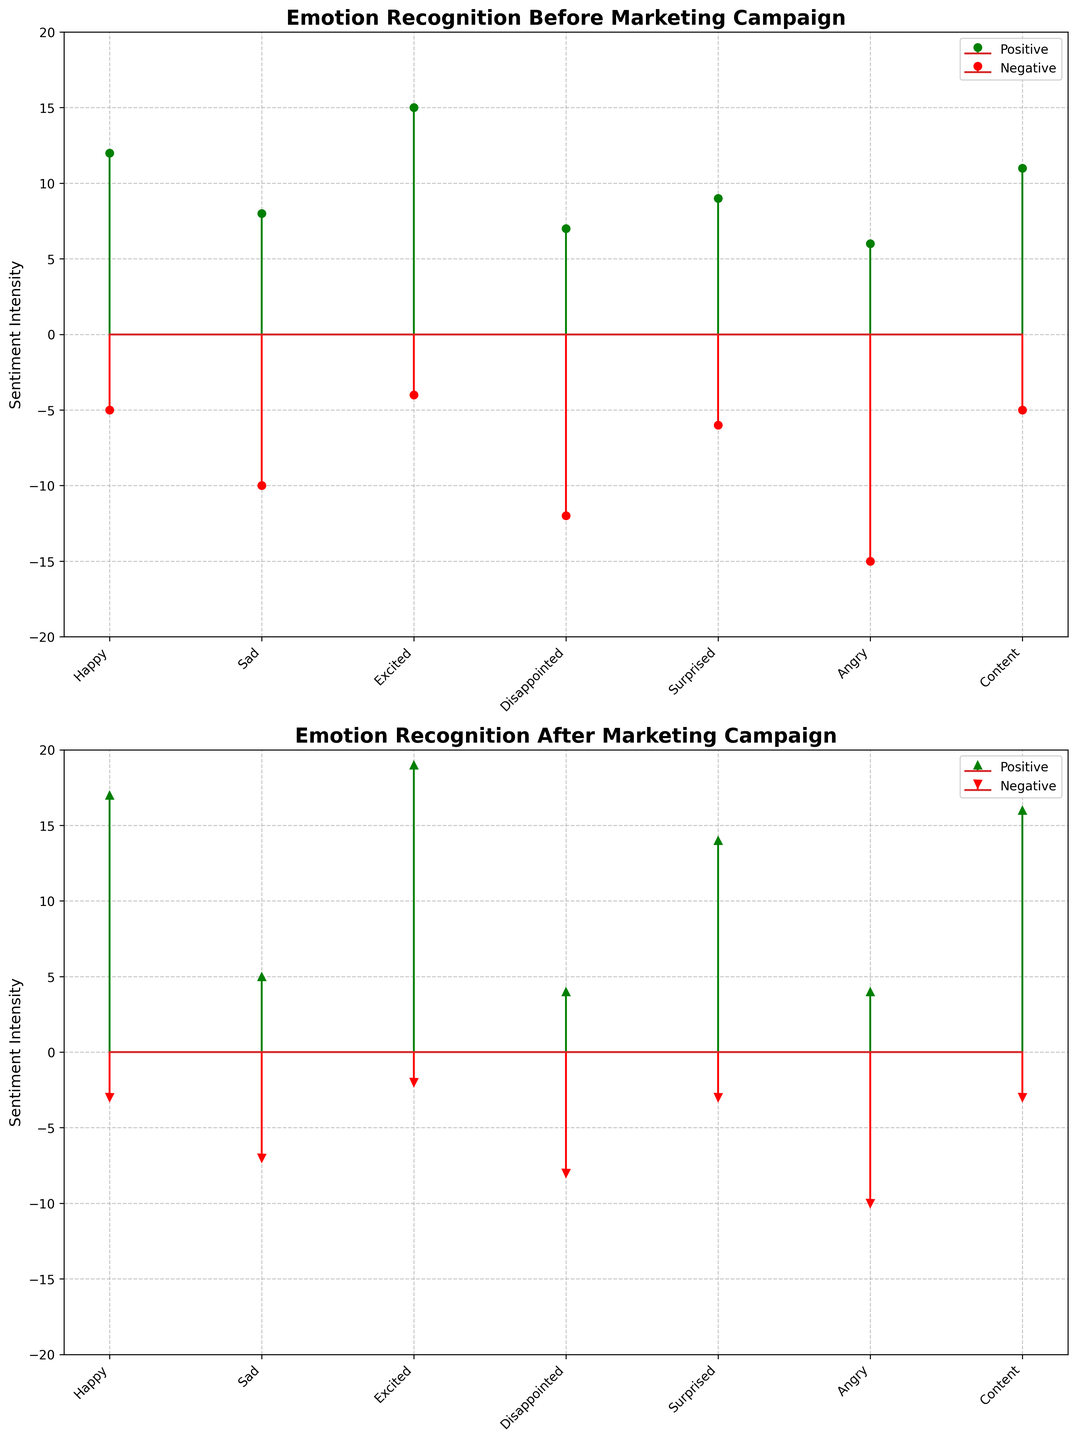What are the two distinct colors used to represent sentiments in the figure? The colors green and red represent positive and negative sentiments, respectively. This is evident in both the "Before Marketing Campaign" and "After Marketing Campaign" subplots.
Answer: Green and Red Which emotion had the highest positive sentiment intensity after the marketing campaign? The "After Marketing Campaign" subplot shows that the "Excited" emotion has the highest positive sentiment intensity with a value of 19, which is more than any other emotion listed.
Answer: Excited Were there any emotions where the negative sentiment intensity decreased after the marketing campaign compared to before? By comparing both subplots, "Sad," "Disappointed," "Surprised," and "Angry" emotions had a decrease in negative sentiment intensity after the marketing campaign.
Answer: Sad, Disappointed, Surprised, Angry Among all emotions, which one showed the most significant positive sentiment improvement after the marketing campaign? By examining the difference between before and after positive sentiment intensities, "Surprised" had the most significant improvement, increasing from 9 to 14, a difference of 5 units.
Answer: Surprised How many emotions showed a decrease in negative sentiment intensity after the marketing campaign? From the subplots, "Sad," "Disappointed," "Surprised," and "Angry" showed decreased negative sentiment intensity after the campaign. There are four such emotions.
Answer: Four What is the sum of positive and negative sentiment intensity for the "Happy" emotion before the marketing campaign? The "Happy" emotion had a positive sentiment intensity of 12 and a negative sentiment intensity of 5 before the marketing campaign. Summing these values gives 12 + 5 = 17.
Answer: 17 Which emotion had the largest absolute difference in negative sentiment intensity before versus after the campaign? The "Angry" emotion had the largest absolute difference in negative sentiment, with a decrease from 15 to 10, resulting in an absolute difference of 5 units.
Answer: Angry What was the total increase in positive sentiment across all emotions after the marketing campaign? Summing up the increases for each emotion: (17-12) + (5-8) + (19-15) + (4-7) + (14-9) + (4-6) + (16-11) = 5 + (-3) + 4 + (-3) + 5 - 2 + 5 = 11 units total increase.
Answer: 11 Considering both positive and negative sentiments, which emotion had the highest combined sentiment intensity after the campaign? The "Excited" emotion had 19 positive and 2 negative sentiments after the campaign, giving a combined intensity of 19 + 2 = 21.
Answer: Excited What was the change in positive sentiment intensity for the "Content" emotion after the marketing campaign? The positive sentiment for "Content" increased from 11 to 16, indicating a change of 16 - 11 = 5 units.
Answer: 5 units 